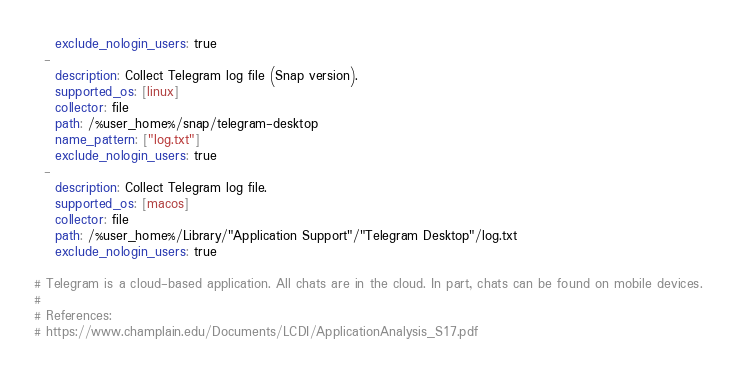Convert code to text. <code><loc_0><loc_0><loc_500><loc_500><_YAML_>    exclude_nologin_users: true
  -
    description: Collect Telegram log file (Snap version).
    supported_os: [linux]
    collector: file
    path: /%user_home%/snap/telegram-desktop
    name_pattern: ["log.txt"]
    exclude_nologin_users: true
  -
    description: Collect Telegram log file.
    supported_os: [macos]
    collector: file
    path: /%user_home%/Library/"Application Support"/"Telegram Desktop"/log.txt
    exclude_nologin_users: true

# Telegram is a cloud-based application. All chats are in the cloud. In part, chats can be found on mobile devices.
#
# References:
# https://www.champlain.edu/Documents/LCDI/ApplicationAnalysis_S17.pdf</code> 